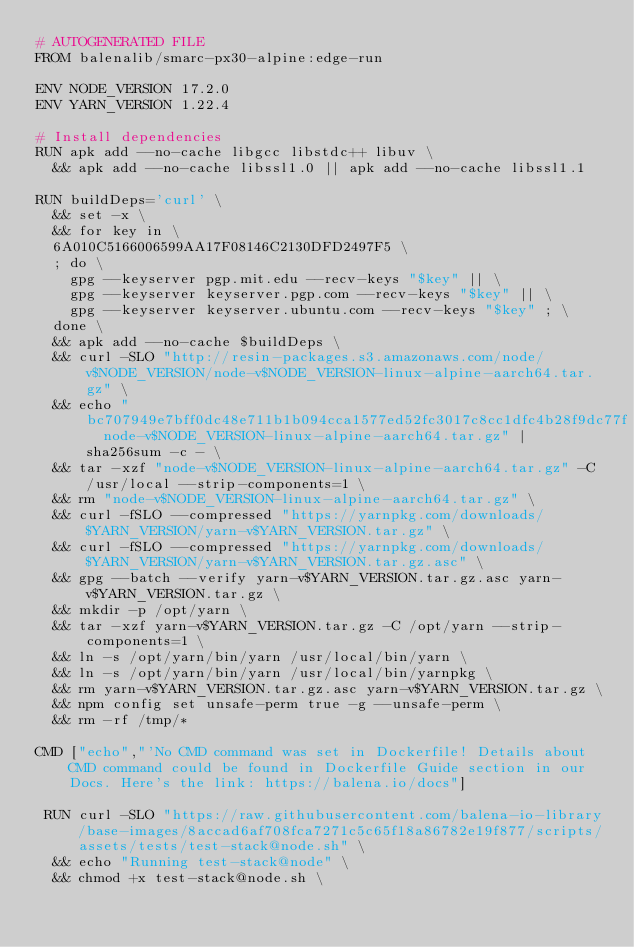<code> <loc_0><loc_0><loc_500><loc_500><_Dockerfile_># AUTOGENERATED FILE
FROM balenalib/smarc-px30-alpine:edge-run

ENV NODE_VERSION 17.2.0
ENV YARN_VERSION 1.22.4

# Install dependencies
RUN apk add --no-cache libgcc libstdc++ libuv \
	&& apk add --no-cache libssl1.0 || apk add --no-cache libssl1.1

RUN buildDeps='curl' \
	&& set -x \
	&& for key in \
	6A010C5166006599AA17F08146C2130DFD2497F5 \
	; do \
		gpg --keyserver pgp.mit.edu --recv-keys "$key" || \
		gpg --keyserver keyserver.pgp.com --recv-keys "$key" || \
		gpg --keyserver keyserver.ubuntu.com --recv-keys "$key" ; \
	done \
	&& apk add --no-cache $buildDeps \
	&& curl -SLO "http://resin-packages.s3.amazonaws.com/node/v$NODE_VERSION/node-v$NODE_VERSION-linux-alpine-aarch64.tar.gz" \
	&& echo "bc707949e7bff0dc48e711b1b094cca1577ed52fc3017c8cc1dfc4b28f9dc77f  node-v$NODE_VERSION-linux-alpine-aarch64.tar.gz" | sha256sum -c - \
	&& tar -xzf "node-v$NODE_VERSION-linux-alpine-aarch64.tar.gz" -C /usr/local --strip-components=1 \
	&& rm "node-v$NODE_VERSION-linux-alpine-aarch64.tar.gz" \
	&& curl -fSLO --compressed "https://yarnpkg.com/downloads/$YARN_VERSION/yarn-v$YARN_VERSION.tar.gz" \
	&& curl -fSLO --compressed "https://yarnpkg.com/downloads/$YARN_VERSION/yarn-v$YARN_VERSION.tar.gz.asc" \
	&& gpg --batch --verify yarn-v$YARN_VERSION.tar.gz.asc yarn-v$YARN_VERSION.tar.gz \
	&& mkdir -p /opt/yarn \
	&& tar -xzf yarn-v$YARN_VERSION.tar.gz -C /opt/yarn --strip-components=1 \
	&& ln -s /opt/yarn/bin/yarn /usr/local/bin/yarn \
	&& ln -s /opt/yarn/bin/yarn /usr/local/bin/yarnpkg \
	&& rm yarn-v$YARN_VERSION.tar.gz.asc yarn-v$YARN_VERSION.tar.gz \
	&& npm config set unsafe-perm true -g --unsafe-perm \
	&& rm -rf /tmp/*

CMD ["echo","'No CMD command was set in Dockerfile! Details about CMD command could be found in Dockerfile Guide section in our Docs. Here's the link: https://balena.io/docs"]

 RUN curl -SLO "https://raw.githubusercontent.com/balena-io-library/base-images/8accad6af708fca7271c5c65f18a86782e19f877/scripts/assets/tests/test-stack@node.sh" \
  && echo "Running test-stack@node" \
  && chmod +x test-stack@node.sh \</code> 